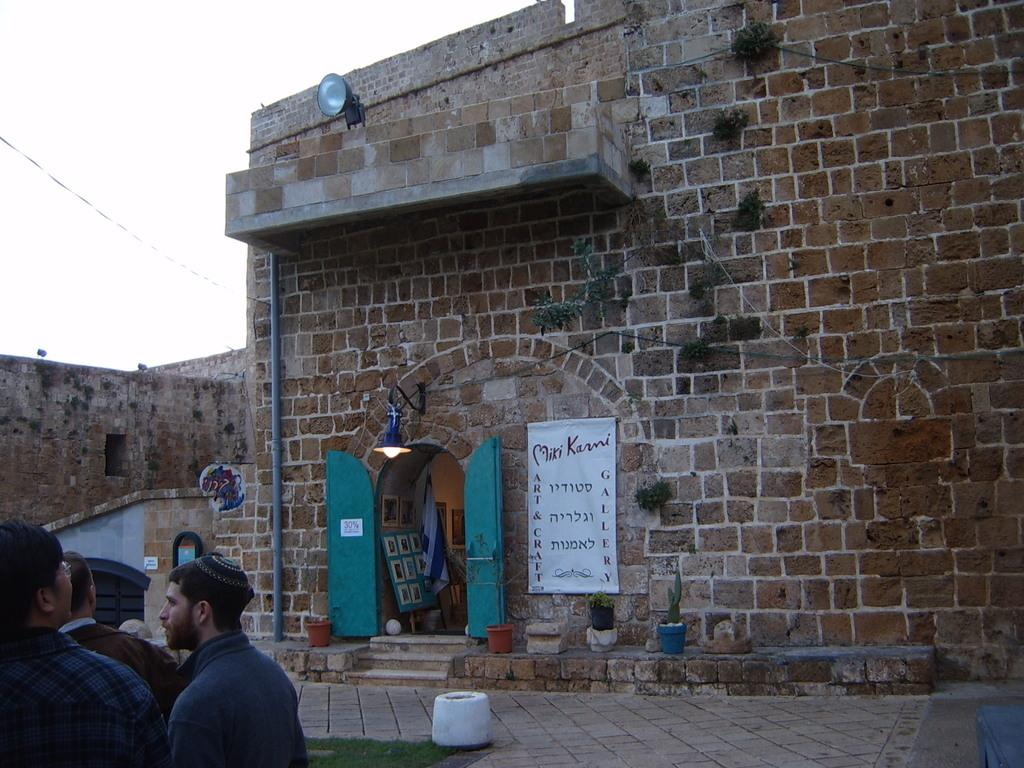What can be seen at the bottom left of the image? There are people standing on the left bottom of the image. What is visible in the background of the image? The sky, clouds, buildings, banners, light, a wall, a door, and a gate are present in the background of the image. How many rods are being used by the people in the image? There is no mention of rods in the image, so it cannot be determined how many are being used. Can you tell me how many pigs are visible in the image? There are no pigs present in the image. 